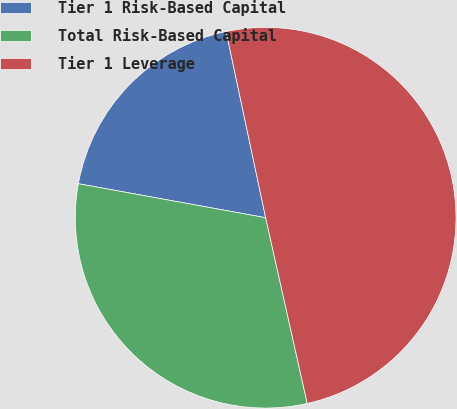<chart> <loc_0><loc_0><loc_500><loc_500><pie_chart><fcel>Tier 1 Risk-Based Capital<fcel>Total Risk-Based Capital<fcel>Tier 1 Leverage<nl><fcel>18.81%<fcel>31.36%<fcel>49.82%<nl></chart> 